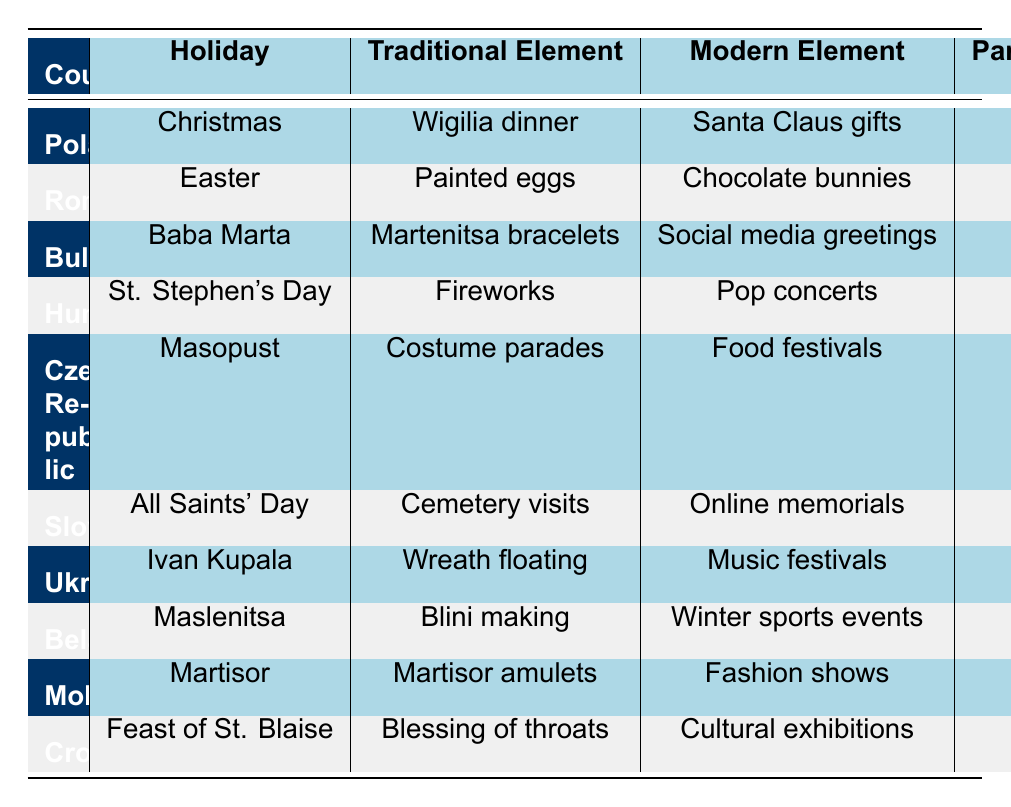What is the participation rate for Christmas celebrations in Poland? The participation rate for Christmas celebrations in Poland is listed in the table under the "Participation Rate (%)" column for the row pertaining to Poland and Christmas, which shows a value of 95.
Answer: 95 Which holiday in the Czech Republic has the lowest participation rate? By reviewing the "Participation Rate (%)" column, it can be seen that "Masopust" in the Czech Republic has the lowest participation rate at 65.
Answer: Masopust Is the traditional element for Easter in Romania "Painted eggs"? The provided data clearly lists the traditional element for Easter in Romania as "Painted eggs" under the respective row, confirming this as true.
Answer: Yes What modern element is associated with the holiday "Maslenitsa" in Belarus? Looking at the row for Belarus and the holiday "Maslenitsa," the modern element is identified as "Winter sports events."
Answer: Winter sports events Which region has a higher participation rate for holiday celebrations: Moldova or Croatia? The participation rate for Moldova is 90, while Croatia's rate is 75. Thus, by comparison, Moldova has a higher participation rate.
Answer: Moldova What is the average participation rate for holidays celebrated in urban areas? First, identify the urban areas: Poland (95), Bulgaria (92), Hungary (78), Slovakia (82), Belarus (85), and Moldova (90). Next, sum these values: 95 + 92 + 78 + 82 + 85 + 90 = 522. Finally, to find the average, divide by the number of urban entries (6): 522 / 6 = 87.
Answer: 87 Does Ukraine celebrate "Ivan Kupala" with modern elements involving music festivals? The data indicates that the modern element associated with "Ivan Kupala" in Ukraine is "Music festivals," confirming that this celebration includes such elements.
Answer: Yes What traditional element is unique to Bulgaria’s "Baba Marta"? The table shows that the traditional element for Bulgaria's "Baba Marta" is "Martenitsa bracelets," which is not listed for any other holiday in the table.
Answer: Martenitsa bracelets Which holiday has a modern element related to social media? Examining the table, it shows that "Baba Marta" in Bulgaria features the modern element "Social media greetings," which indicates its relation to social media.
Answer: Baba Marta 